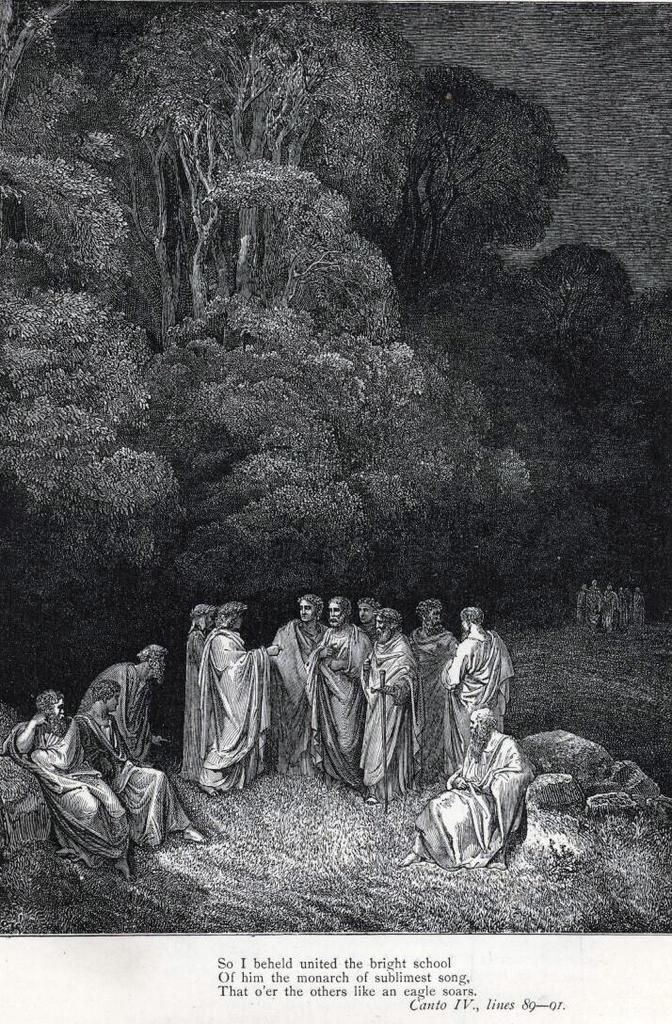Please provide a concise description of this image. This is a black and white picture. There are few people standing and few are sitting on the ground. In the background there are trees,few people and sky. At the bottom there is text written on it. 